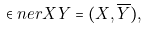<formula> <loc_0><loc_0><loc_500><loc_500>\in n e r { X } { Y } = ( X , \overline { Y } ) ,</formula> 